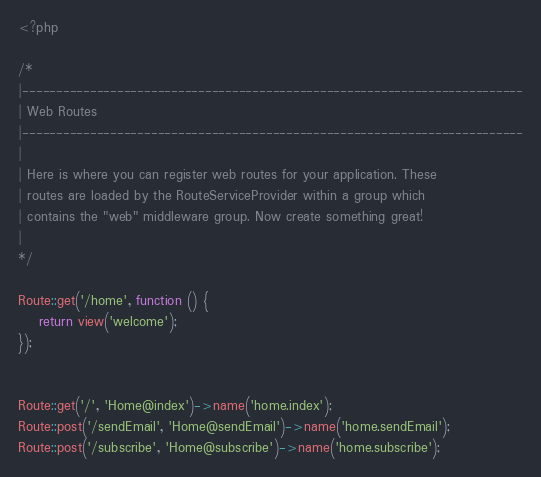<code> <loc_0><loc_0><loc_500><loc_500><_PHP_><?php

/*
|--------------------------------------------------------------------------
| Web Routes
|--------------------------------------------------------------------------
|
| Here is where you can register web routes for your application. These
| routes are loaded by the RouteServiceProvider within a group which
| contains the "web" middleware group. Now create something great!
|
*/

Route::get('/home', function () {
    return view('welcome');
});


Route::get('/', 'Home@index')->name('home.index');
Route::post('/sendEmail', 'Home@sendEmail')->name('home.sendEmail');
Route::post('/subscribe', 'Home@subscribe')->name('home.subscribe');
</code> 